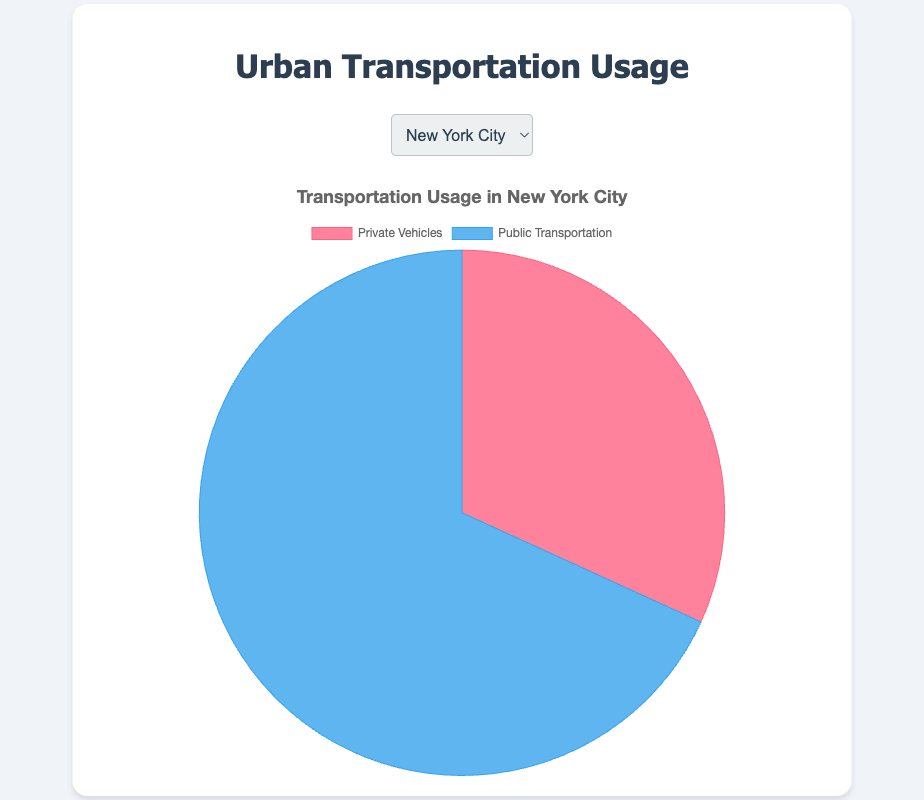What percentage of transportation usage is from private vehicles in New York City? To find the percentage, divide the private vehicle usage by the total usage and then multiply by 100. For New York City, the total usage is 3500000 (Private Vehicles) + 7500000 (Public Transportation) = 11000000. So, the percentage is (3500000 / 11000000) * 100 ≈ 31.82%.
Answer: 31.82% Which city has the highest usage of private vehicles? By examining the private vehicle usage for all cities, Los Angeles has the highest number with 6400000.
Answer: Los Angeles Compare the private vehicle usage between Houston and Phoenix. Which city has a lower usage? Houston has a private vehicle usage of 3400000 while Phoenix has 1700000. Comparing these values, Phoenix has the lower usage.
Answer: Phoenix Which category (Private Vehicles or Public Transportation) is represented by the larger slice in Chicago? Chicago's public transportation usage is 4500000 compared to 2700000 for private vehicles. Therefore, public transportation is represented by the larger slice.
Answer: Public Transportation If we sum the private vehicle usage of Chicago and Houston, does it exceed New York City's public transportation usage? First compute the sum of Chicago and Houston's private vehicle usage: 2700000 + 3400000 = 6100000. New York City's public transportation usage is 7500000, which is more than 6100000.
Answer: No Identify the city with the closest values between private vehicle usage and public transportation usage. To determine this, subtract the smaller value from the larger value for each city. New York City: 7500000 - 3500000 = 4000000, Los Angeles: 6400000 - 2100000 = 4300000, Chicago: 4500000 - 2700000 = 1800000, Houston: 3400000 - 1250000 = 2150000, Phoenix: 1700000 - 800000 = 900000. Chicago has the smallest difference (1800000) indicating the closest values.
Answer: Chicago If Phoenix's public transportation usage increases by 50%, what will be the new percentage of public transportation usage there? Phoenix's current public transportation usage is 800000. A 50% increase is 800000 * 0.5 = 400000. The new usage is 800000 + 400000 = 1200000. The new total usage will be 1700000 (Private Vehicles) + 1200000 (Public Transportation) = 2900000. The percentage is (1200000 / 2900000) * 100 ≈ 41.38%.
Answer: 41.38% Considering only Los Angeles, what fraction of the total transportation usage is from public transportation? The total usage in Los Angeles is 6400000 (Private Vehicles) + 2100000 (Public Transportation) = 8500000. The fraction for public transportation is 2100000 / 8500000, which simplifies to 21/85.
Answer: 21/85 